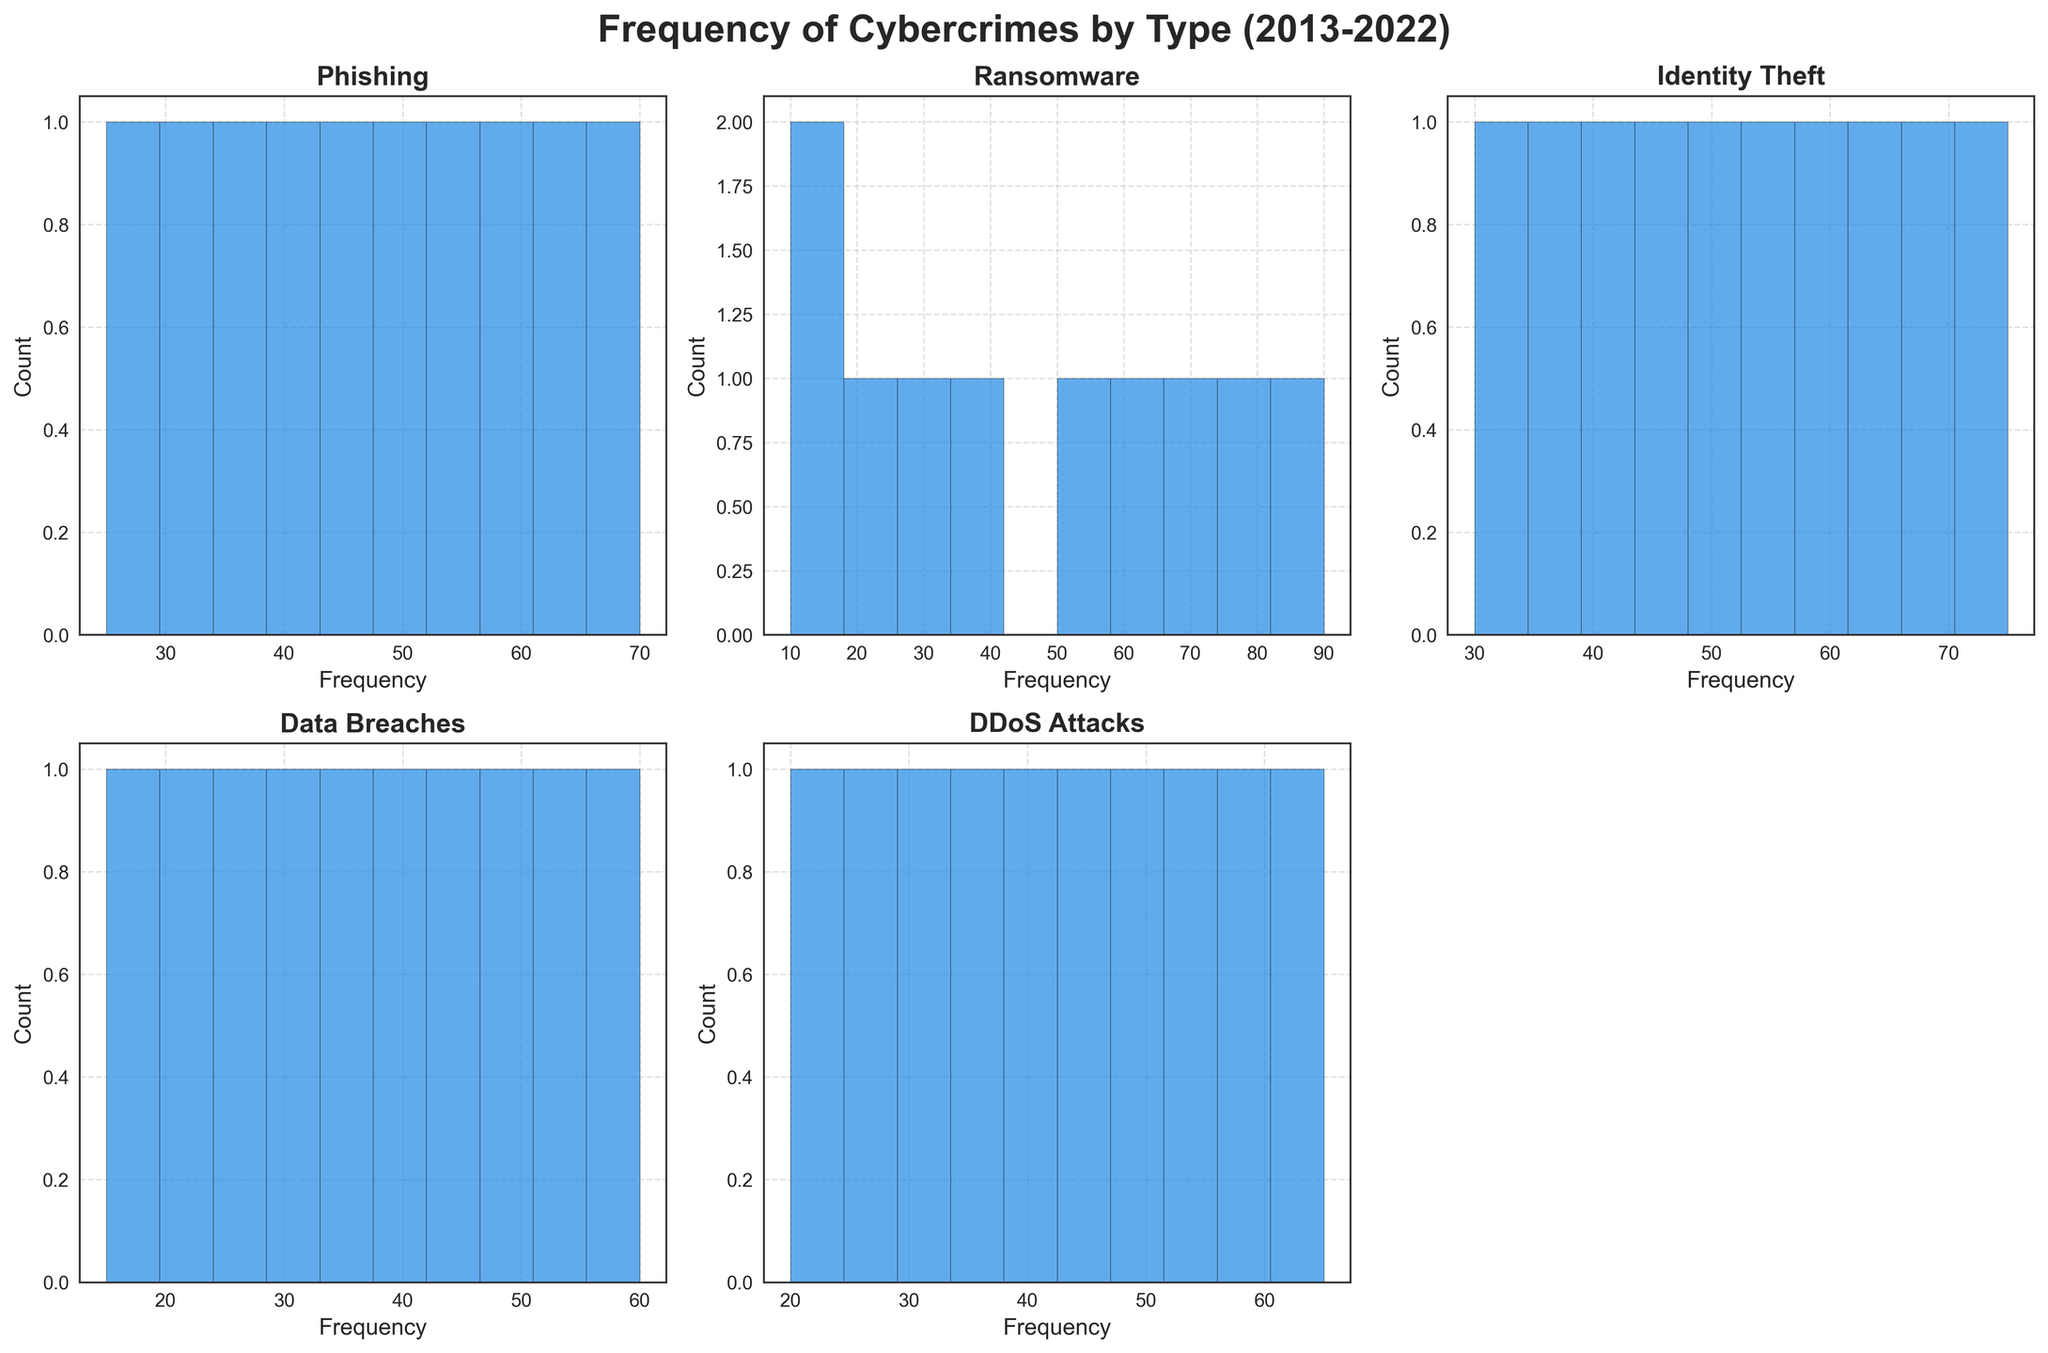What is the title of the entire figure? The title is displayed at the top of the figure, summarizing the content of all subplots. In this case, it provides an overview of what the figure represents.
Answer: Frequency of Cybercrimes by Type (2013-2022) Which subplot shows the data for Phishing? Each subplot is labeled with the crime type it represents. Find the one labeled "Phishing" to locate the correct subplot.
Answer: The subplot in the top left corner How many bins are there in each histogram? By looking at the histogram bars in any subplot, you can count the number of distinct bins. Each histogram subplot contains 10 bins.
Answer: 10 Which type of cybercrime has the highest frequency in 2022? By examining the rightmost bin (2022) in each histogram, identify the one with the highest bar.
Answer: Ransomware Which year shows an equal frequency of Data Breaches and DDoS Attacks? Compare the heights of the bars for each year in the Data Breaches and DDoS Attacks histograms to find the year where they are equal.
Answer: 2013 What is the average frequency of Phishing over the entire period? Add up the frequencies of Phishing for all years and divide by the number of years (10). (25+30+35+40+45+50+55+60+65+70)/10 = 47.5
Answer: 47.5 How does the frequency of Identity Theft in 2018 compare to Ransomware in 2018? Identify and compare the bars for 2018 in both the Identity Theft and Ransomware histograms.
Answer: Identity Theft is higher than Ransomware in 2018 Which year shows the lowest frequency for Data Breaches? Find the shortest bar in the Data Breaches histogram and note the corresponding year.
Answer: 2013 What is the total frequency of DDoS Attacks from 2015 to 2020? Add up the frequencies for DDoS Attacks from 2015 to 2020 (30+35+40+45+50) = 200.
Answer: 200 In which subplot are the frequencies most consistently increasing over the years? Look for the subplot where the bars increase continuously without any drop from year to year.
Answer: Ransomware 